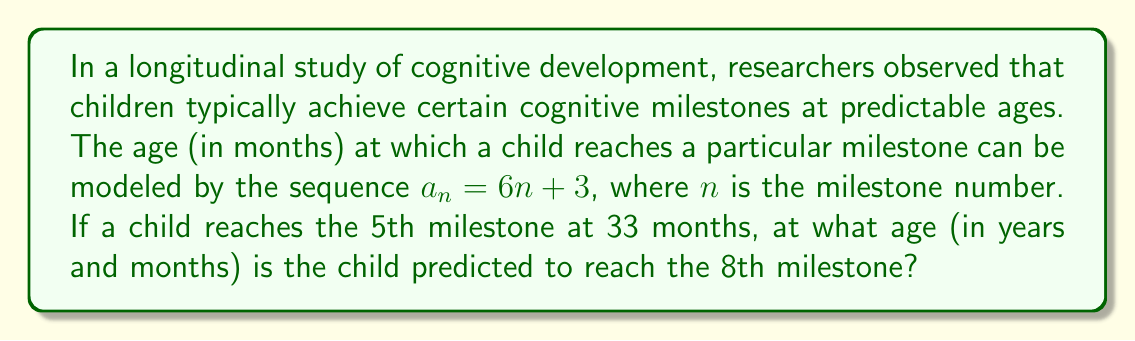Help me with this question. 1. First, we need to verify if the given information fits the model:
   For the 5th milestone ($n = 5$), $a_5 = 6(5) + 3 = 33$ months, which matches the given information.

2. Now, we need to find the age for the 8th milestone ($n = 8$):
   $a_8 = 6(8) + 3 = 48 + 3 = 51$ months

3. Convert 51 months to years and months:
   51 ÷ 12 = 4 remainder 3
   This means 4 years and 3 months

Therefore, the child is predicted to reach the 8th milestone at 4 years and 3 months of age.
Answer: 4 years 3 months 